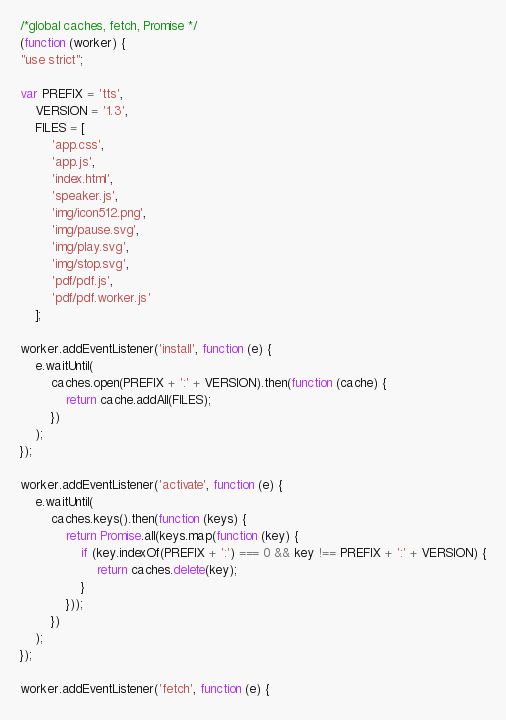Convert code to text. <code><loc_0><loc_0><loc_500><loc_500><_JavaScript_>/*global caches, fetch, Promise */
(function (worker) {
"use strict";

var PREFIX = 'tts',
	VERSION = '1.3',
	FILES = [
		'app.css',
		'app.js',
		'index.html',
		'speaker.js',
		'img/icon512.png',
		'img/pause.svg',
		'img/play.svg',
		'img/stop.svg',
		'pdf/pdf.js',
		'pdf/pdf.worker.js'
	];

worker.addEventListener('install', function (e) {
	e.waitUntil(
		caches.open(PREFIX + ':' + VERSION).then(function (cache) {
			return cache.addAll(FILES);
		})
	);
});

worker.addEventListener('activate', function (e) {
	e.waitUntil(
		caches.keys().then(function (keys) {
			return Promise.all(keys.map(function (key) {
				if (key.indexOf(PREFIX + ':') === 0 && key !== PREFIX + ':' + VERSION) {
					return caches.delete(key);
				}
			}));
		})
	);
});

worker.addEventListener('fetch', function (e) {</code> 